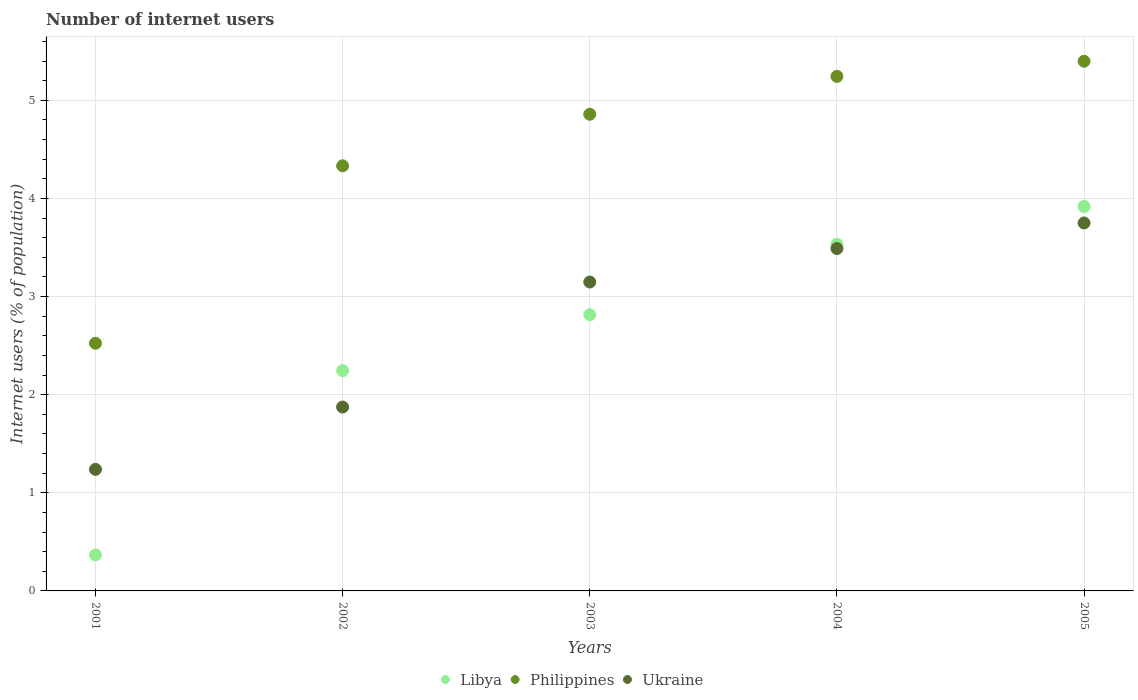How many different coloured dotlines are there?
Give a very brief answer. 3. What is the number of internet users in Libya in 2005?
Your answer should be very brief. 3.92. Across all years, what is the maximum number of internet users in Ukraine?
Keep it short and to the point. 3.75. Across all years, what is the minimum number of internet users in Ukraine?
Give a very brief answer. 1.24. In which year was the number of internet users in Libya maximum?
Your answer should be very brief. 2005. What is the total number of internet users in Ukraine in the graph?
Ensure brevity in your answer.  13.5. What is the difference between the number of internet users in Philippines in 2001 and that in 2002?
Ensure brevity in your answer.  -1.81. What is the difference between the number of internet users in Philippines in 2002 and the number of internet users in Ukraine in 2003?
Keep it short and to the point. 1.18. What is the average number of internet users in Philippines per year?
Your answer should be compact. 4.47. In the year 2005, what is the difference between the number of internet users in Philippines and number of internet users in Libya?
Provide a succinct answer. 1.48. In how many years, is the number of internet users in Ukraine greater than 5 %?
Give a very brief answer. 0. What is the ratio of the number of internet users in Ukraine in 2002 to that in 2003?
Keep it short and to the point. 0.6. What is the difference between the highest and the second highest number of internet users in Philippines?
Your answer should be compact. 0.15. What is the difference between the highest and the lowest number of internet users in Ukraine?
Offer a very short reply. 2.51. In how many years, is the number of internet users in Libya greater than the average number of internet users in Libya taken over all years?
Give a very brief answer. 3. Is it the case that in every year, the sum of the number of internet users in Libya and number of internet users in Philippines  is greater than the number of internet users in Ukraine?
Your response must be concise. Yes. Is the number of internet users in Philippines strictly greater than the number of internet users in Ukraine over the years?
Ensure brevity in your answer.  Yes. Is the number of internet users in Ukraine strictly less than the number of internet users in Philippines over the years?
Offer a terse response. Yes. How many dotlines are there?
Ensure brevity in your answer.  3. Does the graph contain any zero values?
Give a very brief answer. No. Where does the legend appear in the graph?
Your answer should be very brief. Bottom center. How are the legend labels stacked?
Your answer should be compact. Horizontal. What is the title of the graph?
Offer a very short reply. Number of internet users. Does "Euro area" appear as one of the legend labels in the graph?
Provide a short and direct response. No. What is the label or title of the Y-axis?
Make the answer very short. Internet users (% of population). What is the Internet users (% of population) in Libya in 2001?
Give a very brief answer. 0.37. What is the Internet users (% of population) of Philippines in 2001?
Ensure brevity in your answer.  2.52. What is the Internet users (% of population) in Ukraine in 2001?
Offer a terse response. 1.24. What is the Internet users (% of population) in Libya in 2002?
Make the answer very short. 2.24. What is the Internet users (% of population) in Philippines in 2002?
Provide a succinct answer. 4.33. What is the Internet users (% of population) of Ukraine in 2002?
Your answer should be very brief. 1.87. What is the Internet users (% of population) in Libya in 2003?
Your answer should be very brief. 2.81. What is the Internet users (% of population) in Philippines in 2003?
Provide a succinct answer. 4.86. What is the Internet users (% of population) of Ukraine in 2003?
Offer a very short reply. 3.15. What is the Internet users (% of population) of Libya in 2004?
Your response must be concise. 3.53. What is the Internet users (% of population) in Philippines in 2004?
Your answer should be compact. 5.24. What is the Internet users (% of population) in Ukraine in 2004?
Ensure brevity in your answer.  3.49. What is the Internet users (% of population) of Libya in 2005?
Your response must be concise. 3.92. What is the Internet users (% of population) of Philippines in 2005?
Give a very brief answer. 5.4. What is the Internet users (% of population) in Ukraine in 2005?
Provide a short and direct response. 3.75. Across all years, what is the maximum Internet users (% of population) in Libya?
Give a very brief answer. 3.92. Across all years, what is the maximum Internet users (% of population) in Philippines?
Your response must be concise. 5.4. Across all years, what is the maximum Internet users (% of population) in Ukraine?
Provide a succinct answer. 3.75. Across all years, what is the minimum Internet users (% of population) of Libya?
Your response must be concise. 0.37. Across all years, what is the minimum Internet users (% of population) of Philippines?
Offer a terse response. 2.52. Across all years, what is the minimum Internet users (% of population) in Ukraine?
Make the answer very short. 1.24. What is the total Internet users (% of population) in Libya in the graph?
Give a very brief answer. 12.88. What is the total Internet users (% of population) of Philippines in the graph?
Offer a terse response. 22.36. What is the total Internet users (% of population) in Ukraine in the graph?
Give a very brief answer. 13.5. What is the difference between the Internet users (% of population) in Libya in 2001 and that in 2002?
Your answer should be very brief. -1.88. What is the difference between the Internet users (% of population) in Philippines in 2001 and that in 2002?
Provide a succinct answer. -1.81. What is the difference between the Internet users (% of population) in Ukraine in 2001 and that in 2002?
Ensure brevity in your answer.  -0.64. What is the difference between the Internet users (% of population) in Libya in 2001 and that in 2003?
Make the answer very short. -2.45. What is the difference between the Internet users (% of population) of Philippines in 2001 and that in 2003?
Your response must be concise. -2.33. What is the difference between the Internet users (% of population) of Ukraine in 2001 and that in 2003?
Your response must be concise. -1.91. What is the difference between the Internet users (% of population) in Libya in 2001 and that in 2004?
Give a very brief answer. -3.17. What is the difference between the Internet users (% of population) of Philippines in 2001 and that in 2004?
Provide a short and direct response. -2.72. What is the difference between the Internet users (% of population) in Ukraine in 2001 and that in 2004?
Ensure brevity in your answer.  -2.25. What is the difference between the Internet users (% of population) of Libya in 2001 and that in 2005?
Make the answer very short. -3.55. What is the difference between the Internet users (% of population) of Philippines in 2001 and that in 2005?
Your answer should be very brief. -2.87. What is the difference between the Internet users (% of population) of Ukraine in 2001 and that in 2005?
Keep it short and to the point. -2.51. What is the difference between the Internet users (% of population) of Libya in 2002 and that in 2003?
Offer a terse response. -0.57. What is the difference between the Internet users (% of population) of Philippines in 2002 and that in 2003?
Provide a short and direct response. -0.53. What is the difference between the Internet users (% of population) of Ukraine in 2002 and that in 2003?
Your answer should be compact. -1.27. What is the difference between the Internet users (% of population) in Libya in 2002 and that in 2004?
Offer a very short reply. -1.29. What is the difference between the Internet users (% of population) in Philippines in 2002 and that in 2004?
Your answer should be compact. -0.91. What is the difference between the Internet users (% of population) of Ukraine in 2002 and that in 2004?
Provide a short and direct response. -1.62. What is the difference between the Internet users (% of population) of Libya in 2002 and that in 2005?
Your answer should be very brief. -1.67. What is the difference between the Internet users (% of population) in Philippines in 2002 and that in 2005?
Provide a succinct answer. -1.07. What is the difference between the Internet users (% of population) of Ukraine in 2002 and that in 2005?
Your response must be concise. -1.88. What is the difference between the Internet users (% of population) in Libya in 2003 and that in 2004?
Provide a short and direct response. -0.72. What is the difference between the Internet users (% of population) in Philippines in 2003 and that in 2004?
Offer a terse response. -0.39. What is the difference between the Internet users (% of population) of Ukraine in 2003 and that in 2004?
Make the answer very short. -0.34. What is the difference between the Internet users (% of population) of Libya in 2003 and that in 2005?
Your answer should be very brief. -1.1. What is the difference between the Internet users (% of population) in Philippines in 2003 and that in 2005?
Make the answer very short. -0.54. What is the difference between the Internet users (% of population) in Ukraine in 2003 and that in 2005?
Offer a terse response. -0.6. What is the difference between the Internet users (% of population) in Libya in 2004 and that in 2005?
Ensure brevity in your answer.  -0.38. What is the difference between the Internet users (% of population) in Philippines in 2004 and that in 2005?
Give a very brief answer. -0.15. What is the difference between the Internet users (% of population) in Ukraine in 2004 and that in 2005?
Your answer should be very brief. -0.26. What is the difference between the Internet users (% of population) in Libya in 2001 and the Internet users (% of population) in Philippines in 2002?
Provide a short and direct response. -3.97. What is the difference between the Internet users (% of population) in Libya in 2001 and the Internet users (% of population) in Ukraine in 2002?
Ensure brevity in your answer.  -1.51. What is the difference between the Internet users (% of population) in Philippines in 2001 and the Internet users (% of population) in Ukraine in 2002?
Provide a succinct answer. 0.65. What is the difference between the Internet users (% of population) in Libya in 2001 and the Internet users (% of population) in Philippines in 2003?
Your answer should be very brief. -4.49. What is the difference between the Internet users (% of population) of Libya in 2001 and the Internet users (% of population) of Ukraine in 2003?
Provide a succinct answer. -2.78. What is the difference between the Internet users (% of population) in Philippines in 2001 and the Internet users (% of population) in Ukraine in 2003?
Ensure brevity in your answer.  -0.62. What is the difference between the Internet users (% of population) of Libya in 2001 and the Internet users (% of population) of Philippines in 2004?
Make the answer very short. -4.88. What is the difference between the Internet users (% of population) of Libya in 2001 and the Internet users (% of population) of Ukraine in 2004?
Your response must be concise. -3.12. What is the difference between the Internet users (% of population) in Philippines in 2001 and the Internet users (% of population) in Ukraine in 2004?
Your answer should be compact. -0.97. What is the difference between the Internet users (% of population) in Libya in 2001 and the Internet users (% of population) in Philippines in 2005?
Your answer should be compact. -5.03. What is the difference between the Internet users (% of population) in Libya in 2001 and the Internet users (% of population) in Ukraine in 2005?
Your response must be concise. -3.38. What is the difference between the Internet users (% of population) in Philippines in 2001 and the Internet users (% of population) in Ukraine in 2005?
Give a very brief answer. -1.23. What is the difference between the Internet users (% of population) of Libya in 2002 and the Internet users (% of population) of Philippines in 2003?
Provide a succinct answer. -2.61. What is the difference between the Internet users (% of population) of Libya in 2002 and the Internet users (% of population) of Ukraine in 2003?
Keep it short and to the point. -0.9. What is the difference between the Internet users (% of population) in Philippines in 2002 and the Internet users (% of population) in Ukraine in 2003?
Your answer should be very brief. 1.18. What is the difference between the Internet users (% of population) in Libya in 2002 and the Internet users (% of population) in Philippines in 2004?
Offer a terse response. -3. What is the difference between the Internet users (% of population) of Libya in 2002 and the Internet users (% of population) of Ukraine in 2004?
Offer a very short reply. -1.25. What is the difference between the Internet users (% of population) of Philippines in 2002 and the Internet users (% of population) of Ukraine in 2004?
Your answer should be very brief. 0.84. What is the difference between the Internet users (% of population) of Libya in 2002 and the Internet users (% of population) of Philippines in 2005?
Keep it short and to the point. -3.15. What is the difference between the Internet users (% of population) in Libya in 2002 and the Internet users (% of population) in Ukraine in 2005?
Provide a succinct answer. -1.51. What is the difference between the Internet users (% of population) in Philippines in 2002 and the Internet users (% of population) in Ukraine in 2005?
Your answer should be very brief. 0.58. What is the difference between the Internet users (% of population) in Libya in 2003 and the Internet users (% of population) in Philippines in 2004?
Ensure brevity in your answer.  -2.43. What is the difference between the Internet users (% of population) in Libya in 2003 and the Internet users (% of population) in Ukraine in 2004?
Your answer should be very brief. -0.68. What is the difference between the Internet users (% of population) in Philippines in 2003 and the Internet users (% of population) in Ukraine in 2004?
Your response must be concise. 1.37. What is the difference between the Internet users (% of population) of Libya in 2003 and the Internet users (% of population) of Philippines in 2005?
Ensure brevity in your answer.  -2.58. What is the difference between the Internet users (% of population) in Libya in 2003 and the Internet users (% of population) in Ukraine in 2005?
Give a very brief answer. -0.94. What is the difference between the Internet users (% of population) of Philippines in 2003 and the Internet users (% of population) of Ukraine in 2005?
Give a very brief answer. 1.11. What is the difference between the Internet users (% of population) in Libya in 2004 and the Internet users (% of population) in Philippines in 2005?
Your answer should be very brief. -1.86. What is the difference between the Internet users (% of population) of Libya in 2004 and the Internet users (% of population) of Ukraine in 2005?
Make the answer very short. -0.22. What is the difference between the Internet users (% of population) in Philippines in 2004 and the Internet users (% of population) in Ukraine in 2005?
Keep it short and to the point. 1.49. What is the average Internet users (% of population) of Libya per year?
Keep it short and to the point. 2.58. What is the average Internet users (% of population) of Philippines per year?
Make the answer very short. 4.47. What is the average Internet users (% of population) of Ukraine per year?
Provide a succinct answer. 2.7. In the year 2001, what is the difference between the Internet users (% of population) of Libya and Internet users (% of population) of Philippines?
Offer a terse response. -2.16. In the year 2001, what is the difference between the Internet users (% of population) in Libya and Internet users (% of population) in Ukraine?
Your answer should be very brief. -0.87. In the year 2001, what is the difference between the Internet users (% of population) of Philippines and Internet users (% of population) of Ukraine?
Offer a terse response. 1.29. In the year 2002, what is the difference between the Internet users (% of population) of Libya and Internet users (% of population) of Philippines?
Provide a short and direct response. -2.09. In the year 2002, what is the difference between the Internet users (% of population) in Libya and Internet users (% of population) in Ukraine?
Your answer should be compact. 0.37. In the year 2002, what is the difference between the Internet users (% of population) in Philippines and Internet users (% of population) in Ukraine?
Offer a very short reply. 2.46. In the year 2003, what is the difference between the Internet users (% of population) in Libya and Internet users (% of population) in Philippines?
Offer a terse response. -2.04. In the year 2003, what is the difference between the Internet users (% of population) in Libya and Internet users (% of population) in Ukraine?
Provide a short and direct response. -0.33. In the year 2003, what is the difference between the Internet users (% of population) of Philippines and Internet users (% of population) of Ukraine?
Your answer should be compact. 1.71. In the year 2004, what is the difference between the Internet users (% of population) in Libya and Internet users (% of population) in Philippines?
Offer a very short reply. -1.71. In the year 2004, what is the difference between the Internet users (% of population) of Libya and Internet users (% of population) of Ukraine?
Offer a terse response. 0.04. In the year 2004, what is the difference between the Internet users (% of population) of Philippines and Internet users (% of population) of Ukraine?
Offer a terse response. 1.75. In the year 2005, what is the difference between the Internet users (% of population) in Libya and Internet users (% of population) in Philippines?
Offer a terse response. -1.48. In the year 2005, what is the difference between the Internet users (% of population) of Libya and Internet users (% of population) of Ukraine?
Give a very brief answer. 0.17. In the year 2005, what is the difference between the Internet users (% of population) in Philippines and Internet users (% of population) in Ukraine?
Make the answer very short. 1.65. What is the ratio of the Internet users (% of population) in Libya in 2001 to that in 2002?
Make the answer very short. 0.16. What is the ratio of the Internet users (% of population) of Philippines in 2001 to that in 2002?
Offer a terse response. 0.58. What is the ratio of the Internet users (% of population) in Ukraine in 2001 to that in 2002?
Offer a terse response. 0.66. What is the ratio of the Internet users (% of population) of Libya in 2001 to that in 2003?
Make the answer very short. 0.13. What is the ratio of the Internet users (% of population) in Philippines in 2001 to that in 2003?
Provide a succinct answer. 0.52. What is the ratio of the Internet users (% of population) in Ukraine in 2001 to that in 2003?
Offer a terse response. 0.39. What is the ratio of the Internet users (% of population) in Libya in 2001 to that in 2004?
Give a very brief answer. 0.1. What is the ratio of the Internet users (% of population) of Philippines in 2001 to that in 2004?
Ensure brevity in your answer.  0.48. What is the ratio of the Internet users (% of population) in Ukraine in 2001 to that in 2004?
Give a very brief answer. 0.35. What is the ratio of the Internet users (% of population) in Libya in 2001 to that in 2005?
Provide a short and direct response. 0.09. What is the ratio of the Internet users (% of population) in Philippines in 2001 to that in 2005?
Your response must be concise. 0.47. What is the ratio of the Internet users (% of population) of Ukraine in 2001 to that in 2005?
Make the answer very short. 0.33. What is the ratio of the Internet users (% of population) of Libya in 2002 to that in 2003?
Provide a short and direct response. 0.8. What is the ratio of the Internet users (% of population) in Philippines in 2002 to that in 2003?
Offer a terse response. 0.89. What is the ratio of the Internet users (% of population) of Ukraine in 2002 to that in 2003?
Offer a terse response. 0.6. What is the ratio of the Internet users (% of population) of Libya in 2002 to that in 2004?
Keep it short and to the point. 0.64. What is the ratio of the Internet users (% of population) in Philippines in 2002 to that in 2004?
Offer a terse response. 0.83. What is the ratio of the Internet users (% of population) of Ukraine in 2002 to that in 2004?
Provide a succinct answer. 0.54. What is the ratio of the Internet users (% of population) of Libya in 2002 to that in 2005?
Your answer should be very brief. 0.57. What is the ratio of the Internet users (% of population) in Philippines in 2002 to that in 2005?
Provide a short and direct response. 0.8. What is the ratio of the Internet users (% of population) in Ukraine in 2002 to that in 2005?
Provide a short and direct response. 0.5. What is the ratio of the Internet users (% of population) of Libya in 2003 to that in 2004?
Offer a very short reply. 0.8. What is the ratio of the Internet users (% of population) of Philippines in 2003 to that in 2004?
Make the answer very short. 0.93. What is the ratio of the Internet users (% of population) in Ukraine in 2003 to that in 2004?
Provide a short and direct response. 0.9. What is the ratio of the Internet users (% of population) in Libya in 2003 to that in 2005?
Your answer should be compact. 0.72. What is the ratio of the Internet users (% of population) of Ukraine in 2003 to that in 2005?
Offer a very short reply. 0.84. What is the ratio of the Internet users (% of population) of Libya in 2004 to that in 2005?
Keep it short and to the point. 0.9. What is the ratio of the Internet users (% of population) of Philippines in 2004 to that in 2005?
Make the answer very short. 0.97. What is the ratio of the Internet users (% of population) in Ukraine in 2004 to that in 2005?
Your answer should be compact. 0.93. What is the difference between the highest and the second highest Internet users (% of population) in Libya?
Provide a succinct answer. 0.38. What is the difference between the highest and the second highest Internet users (% of population) in Philippines?
Ensure brevity in your answer.  0.15. What is the difference between the highest and the second highest Internet users (% of population) in Ukraine?
Make the answer very short. 0.26. What is the difference between the highest and the lowest Internet users (% of population) of Libya?
Your response must be concise. 3.55. What is the difference between the highest and the lowest Internet users (% of population) in Philippines?
Provide a succinct answer. 2.87. What is the difference between the highest and the lowest Internet users (% of population) in Ukraine?
Offer a very short reply. 2.51. 